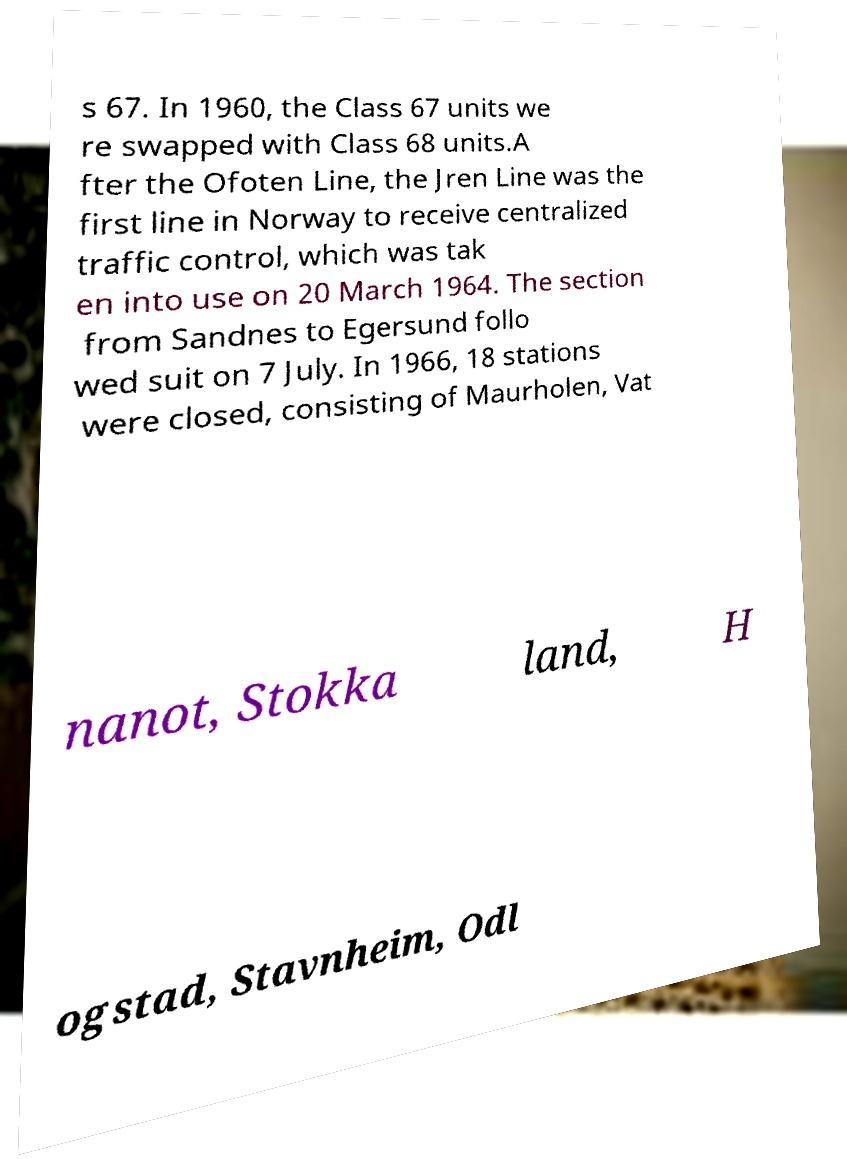Can you read and provide the text displayed in the image?This photo seems to have some interesting text. Can you extract and type it out for me? s 67. In 1960, the Class 67 units we re swapped with Class 68 units.A fter the Ofoten Line, the Jren Line was the first line in Norway to receive centralized traffic control, which was tak en into use on 20 March 1964. The section from Sandnes to Egersund follo wed suit on 7 July. In 1966, 18 stations were closed, consisting of Maurholen, Vat nanot, Stokka land, H ogstad, Stavnheim, Odl 